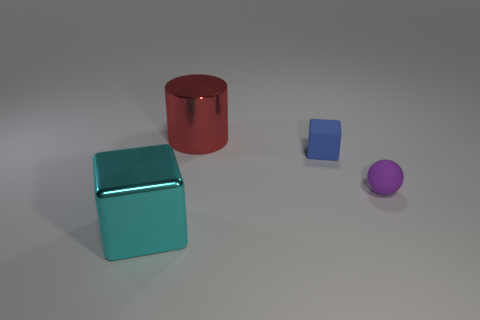Is there a big red cylinder that is on the left side of the metal object that is behind the blue object?
Provide a short and direct response. No. There is a object that is both behind the cyan block and in front of the matte block; what is its color?
Offer a very short reply. Purple. Are there any large red objects in front of the large shiny object that is on the right side of the shiny thing in front of the large red thing?
Keep it short and to the point. No. There is a cyan metal object that is the same shape as the blue object; what size is it?
Ensure brevity in your answer.  Large. Is there any other thing that is the same material as the purple sphere?
Keep it short and to the point. Yes. Are any cyan things visible?
Provide a succinct answer. Yes. There is a big metal cylinder; is it the same color as the metal object in front of the small sphere?
Offer a very short reply. No. What size is the block that is on the right side of the big thing that is behind the tiny matte thing that is in front of the tiny matte cube?
Your response must be concise. Small. How many tiny rubber things have the same color as the matte ball?
Offer a terse response. 0. How many things are cyan blocks or rubber things that are in front of the rubber block?
Offer a terse response. 2. 